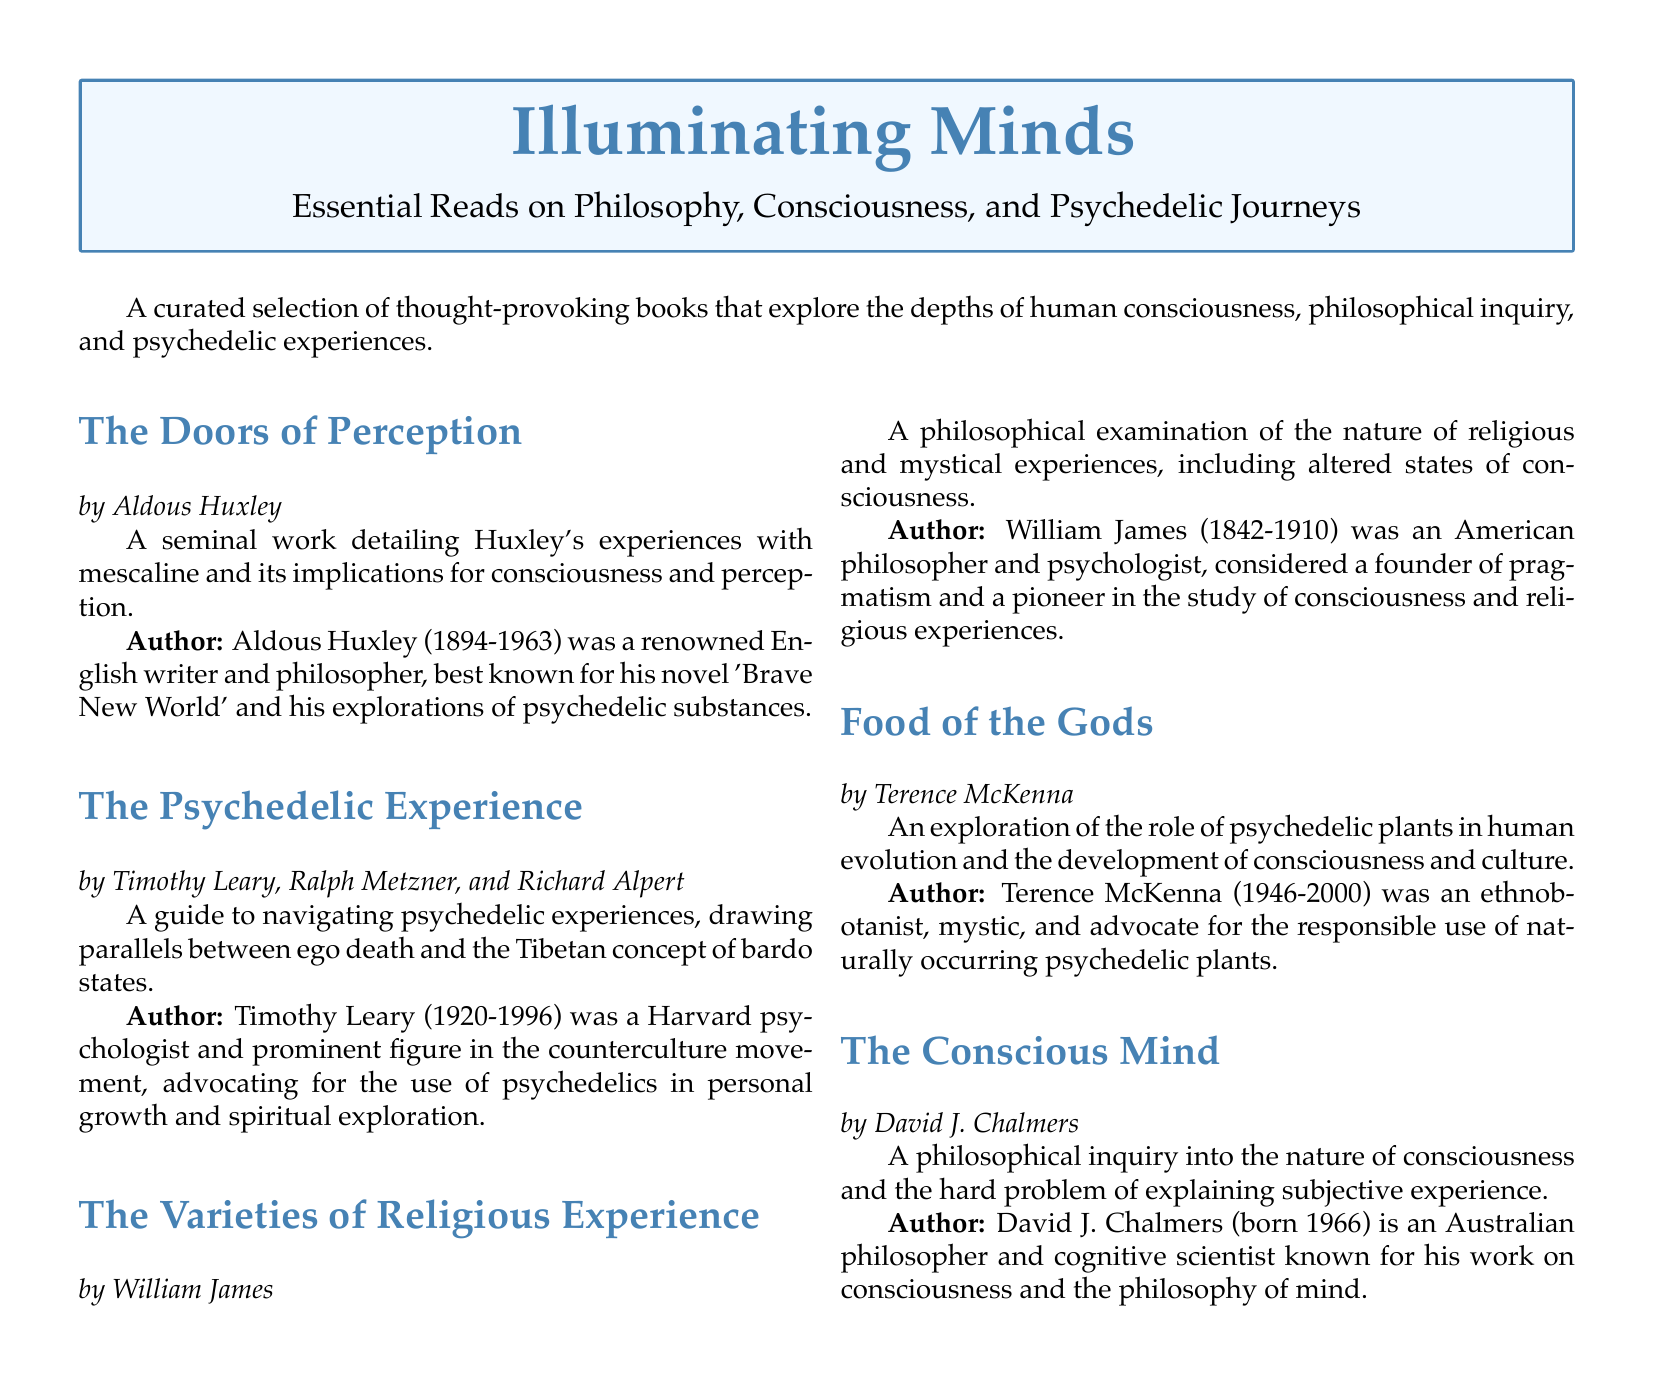What is the title of the first book listed? The first book listed is always at the top of the section, which in this case is "The Doors of Perception."
Answer: The Doors of Perception Who is the author of "Food of the Gods"? The author information is provided below each book title. For "Food of the Gods," the author is Terence McKenna.
Answer: Terence McKenna What year was Timothy Leary born? The author section includes Timothy Leary's lifespan, with 1920 as his birth year.
Answer: 1920 How many authors contributed to "The Psychedelic Experience"? The title section lists three authors for this book: Timothy Leary, Ralph Metzner, and Richard Alpert.
Answer: Three Which book is known for its exploration of the "hard problem" of consciousness? The document describes each book, and "The Conscious Mind" focuses on the hard problem of consciousness.
Answer: The Conscious Mind Which philosopher is associated with the concept of pragmatism? The biography of William James indicates he was considered a founder of pragmatism.
Answer: William James In what year did Aldous Huxley pass away? The author section indicates that Aldous Huxley lived from 1894 to 1963, marking 1963 as his year of death.
Answer: 1963 What theme do all these books share? The introductory sentence states they explore the depths of human consciousness, philosophical inquiry, and psychedelic experiences.
Answer: Human consciousness 